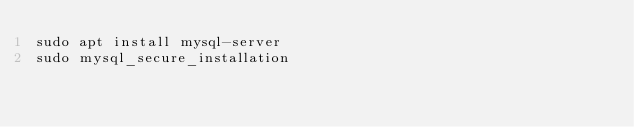<code> <loc_0><loc_0><loc_500><loc_500><_Bash_>sudo apt install mysql-server
sudo mysql_secure_installation
</code> 